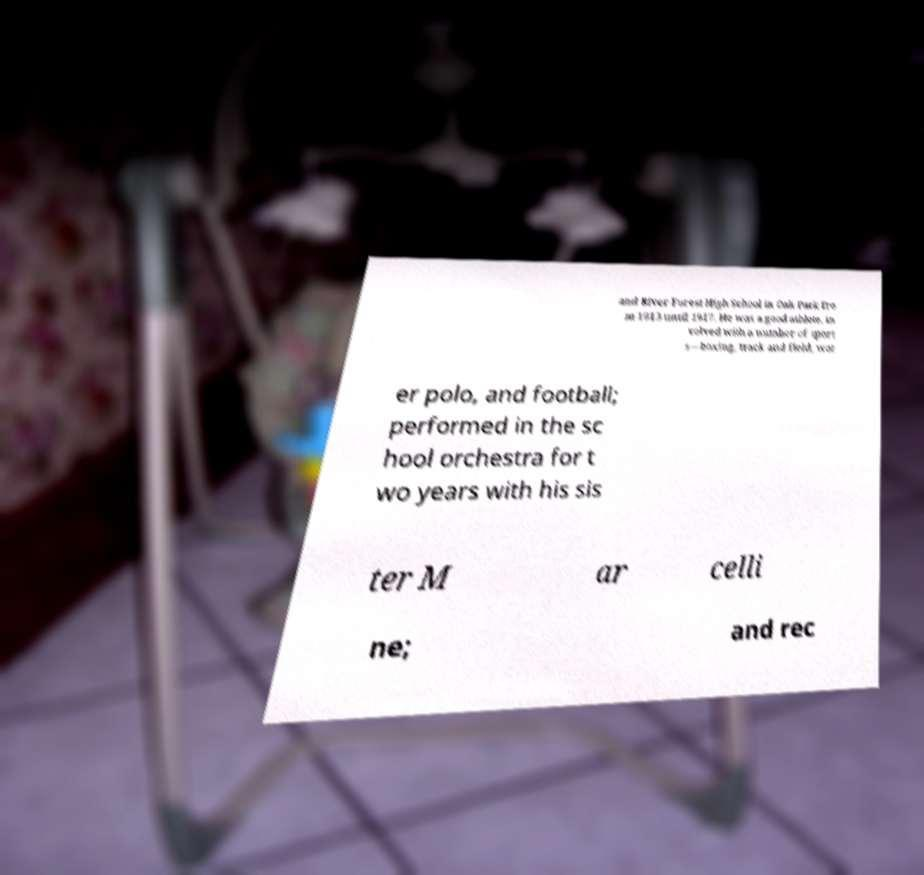Please identify and transcribe the text found in this image. and River Forest High School in Oak Park fro m 1913 until 1917. He was a good athlete, in volved with a number of sport s—boxing, track and field, wat er polo, and football; performed in the sc hool orchestra for t wo years with his sis ter M ar celli ne; and rec 